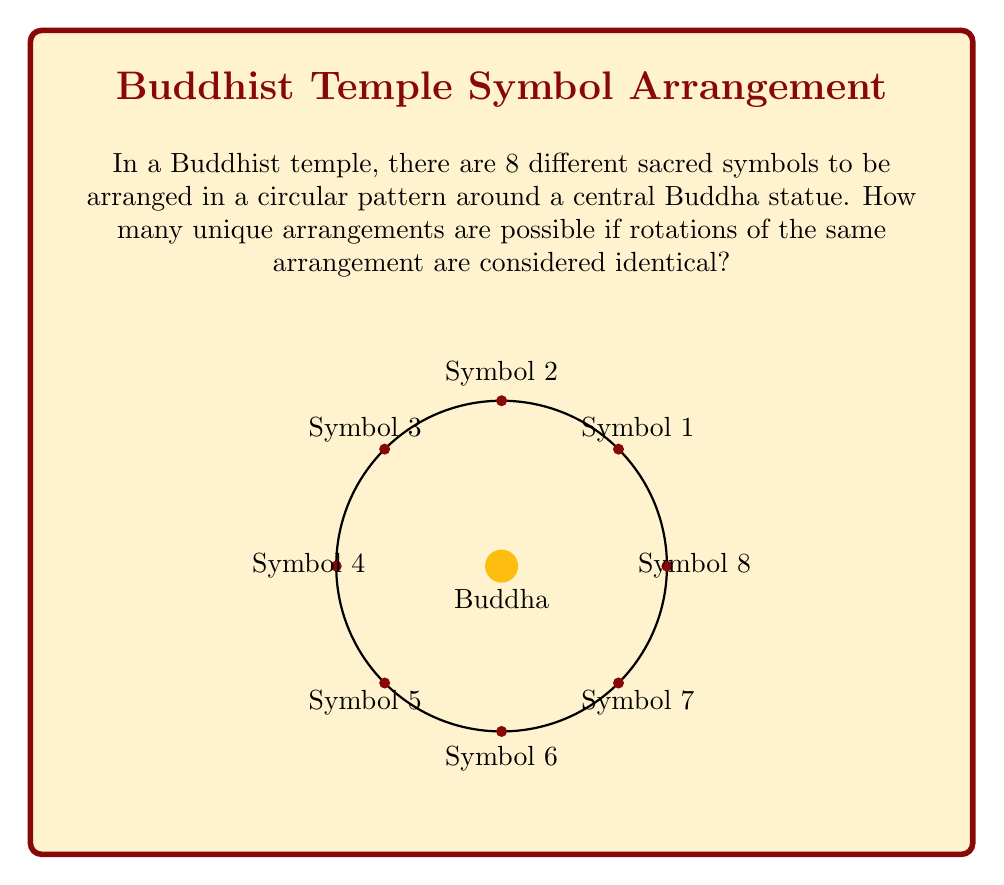What is the answer to this math problem? Let's approach this step-by-step:

1) First, we need to recognize that this is a circular permutation problem. In a circular arrangement, rotations of the same arrangement are considered identical.

2) For linear arrangements of n distinct objects, we would have n! permutations. However, for circular arrangements, we divide by n to account for the rotational symmetry.

3) In this case, we have 8 distinct symbols to arrange.

4) The formula for circular permutations of n distinct objects is:

   $$(n-1)!$$

5) Plugging in our value of n = 8:

   $$(8-1)! = 7!$$

6) Let's calculate this:
   
   $$7! = 7 \times 6 \times 5 \times 4 \times 3 \times 2 \times 1 = 5040$$

Therefore, there are 5040 unique arrangements of the 8 Buddhist symbols around the central Buddha statue.
Answer: 5040 